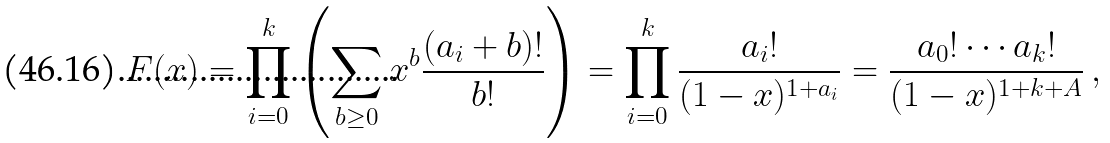<formula> <loc_0><loc_0><loc_500><loc_500>F ( x ) = \prod _ { i = 0 } ^ { k } \left ( \sum _ { b \geq 0 } x ^ { b } \frac { ( a _ { i } + b ) ! } { b ! } \right ) = \prod _ { i = 0 } ^ { k } \frac { a _ { i } ! } { ( 1 - x ) ^ { 1 + a _ { i } } } = \frac { a _ { 0 } ! \cdots a _ { k } ! } { ( 1 - x ) ^ { 1 + k + A } } \, ,</formula> 